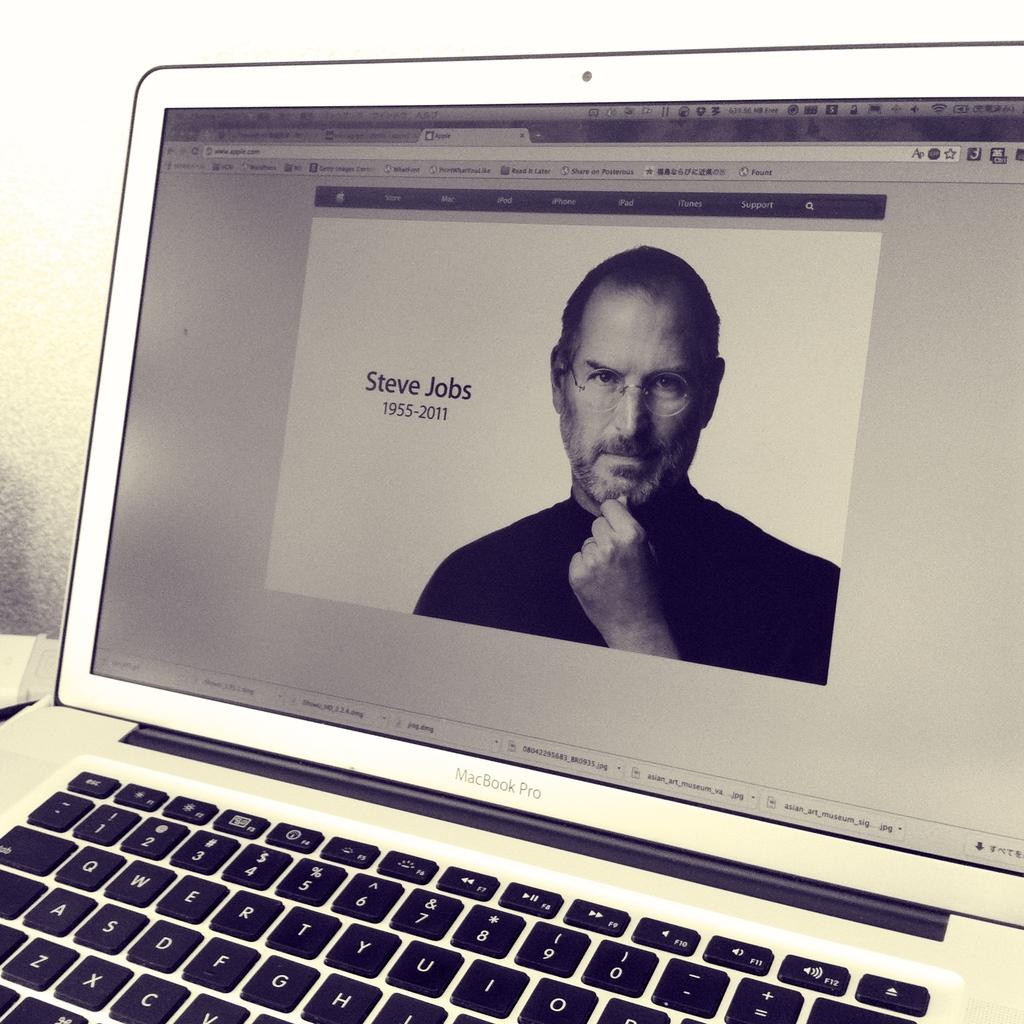What electronic device is visible in the image? There is a laptop in the image. What is displayed on the laptop screen? There is a person's image on the laptop screen. What can be seen behind the laptop? There appears to be a wall behind the laptop. What type of oatmeal is being served in the image? There is no oatmeal present in the image. What is the person using to brush their teeth in the image? There is no toothbrush or tooth-related activity depicted in the image. 